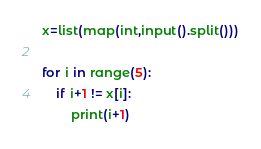Convert code to text. <code><loc_0><loc_0><loc_500><loc_500><_Python_>x=list(map(int,input().split()))

for i in range(5):
    if i+1 != x[i]:
        print(i+1)
</code> 